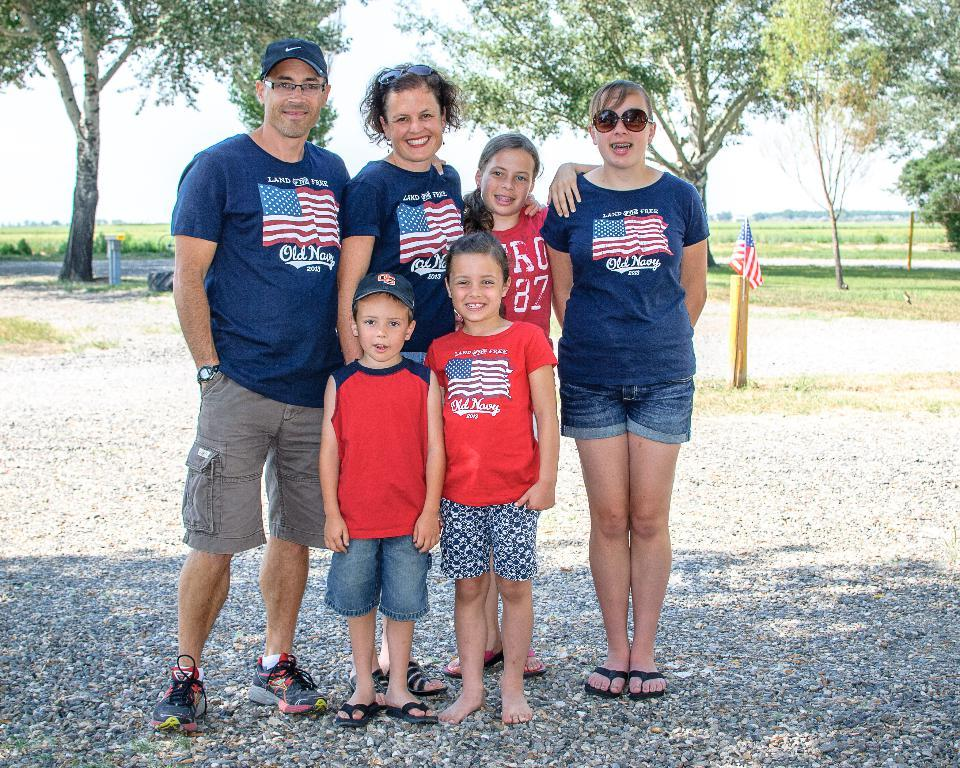What are the people in the image doing? The group of people is standing on the ground in the image. What type of objects can be seen on the ground? There are stones visible in the image. What is attached to the wooden pole in the image? There is a flag in the image. What other objects can be seen on the ground? There is a tire in the image. What type of vegetation is present in the image? There are trees and grass in the image. What is visible in the sky in the image? The sky is visible in the image, and it looks cloudy. Where is the library located in the image? There is no library present in the image. What type of formation is the group of people creating in the image? The image does not show the group of people creating any specific formation or pattern. 